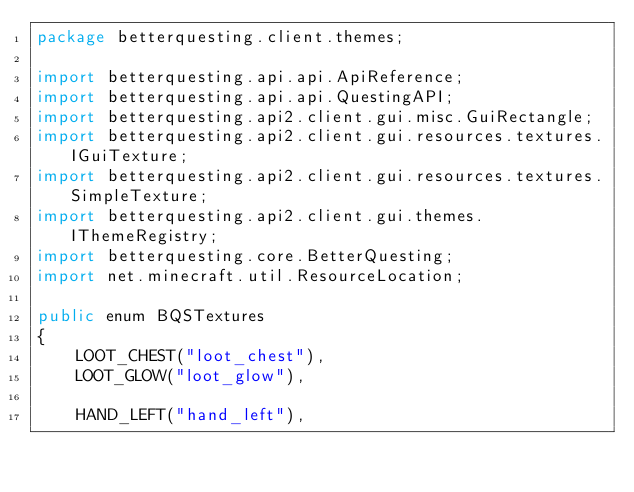Convert code to text. <code><loc_0><loc_0><loc_500><loc_500><_Java_>package betterquesting.client.themes;

import betterquesting.api.api.ApiReference;
import betterquesting.api.api.QuestingAPI;
import betterquesting.api2.client.gui.misc.GuiRectangle;
import betterquesting.api2.client.gui.resources.textures.IGuiTexture;
import betterquesting.api2.client.gui.resources.textures.SimpleTexture;
import betterquesting.api2.client.gui.themes.IThemeRegistry;
import betterquesting.core.BetterQuesting;
import net.minecraft.util.ResourceLocation;

public enum BQSTextures
{
    LOOT_CHEST("loot_chest"),
    LOOT_GLOW("loot_glow"),
    
    HAND_LEFT("hand_left"),</code> 